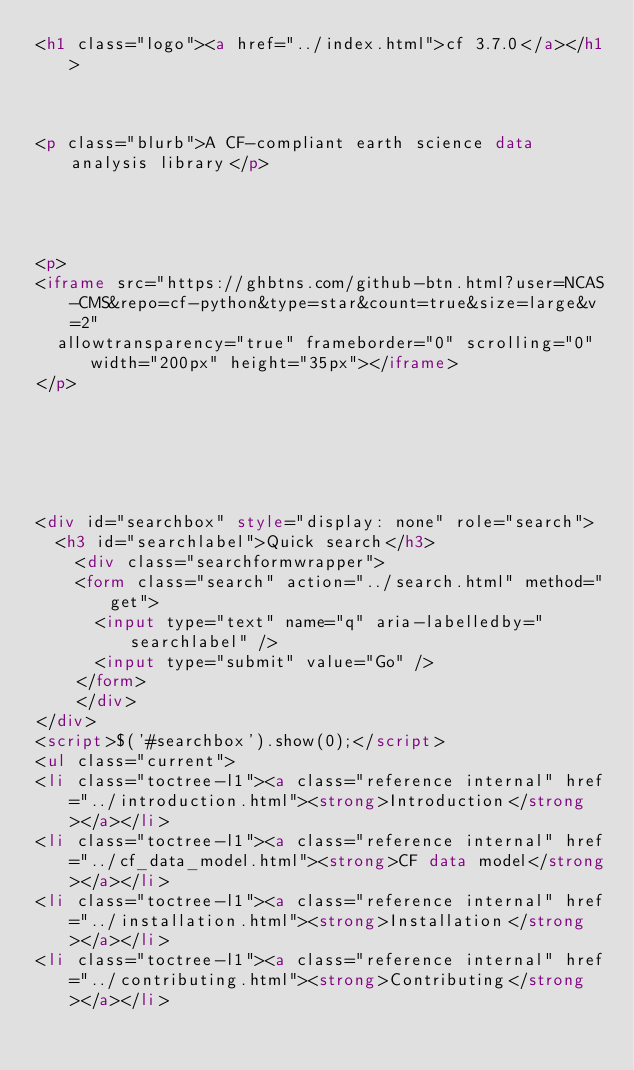Convert code to text. <code><loc_0><loc_0><loc_500><loc_500><_HTML_><h1 class="logo"><a href="../index.html">cf 3.7.0</a></h1>



<p class="blurb">A CF-compliant earth science data analysis library</p>




<p>
<iframe src="https://ghbtns.com/github-btn.html?user=NCAS-CMS&repo=cf-python&type=star&count=true&size=large&v=2"
  allowtransparency="true" frameborder="0" scrolling="0" width="200px" height="35px"></iframe>
</p>






<div id="searchbox" style="display: none" role="search">
  <h3 id="searchlabel">Quick search</h3>
    <div class="searchformwrapper">
    <form class="search" action="../search.html" method="get">
      <input type="text" name="q" aria-labelledby="searchlabel" />
      <input type="submit" value="Go" />
    </form>
    </div>
</div>
<script>$('#searchbox').show(0);</script>
<ul class="current">
<li class="toctree-l1"><a class="reference internal" href="../introduction.html"><strong>Introduction</strong></a></li>
<li class="toctree-l1"><a class="reference internal" href="../cf_data_model.html"><strong>CF data model</strong></a></li>
<li class="toctree-l1"><a class="reference internal" href="../installation.html"><strong>Installation</strong></a></li>
<li class="toctree-l1"><a class="reference internal" href="../contributing.html"><strong>Contributing</strong></a></li></code> 